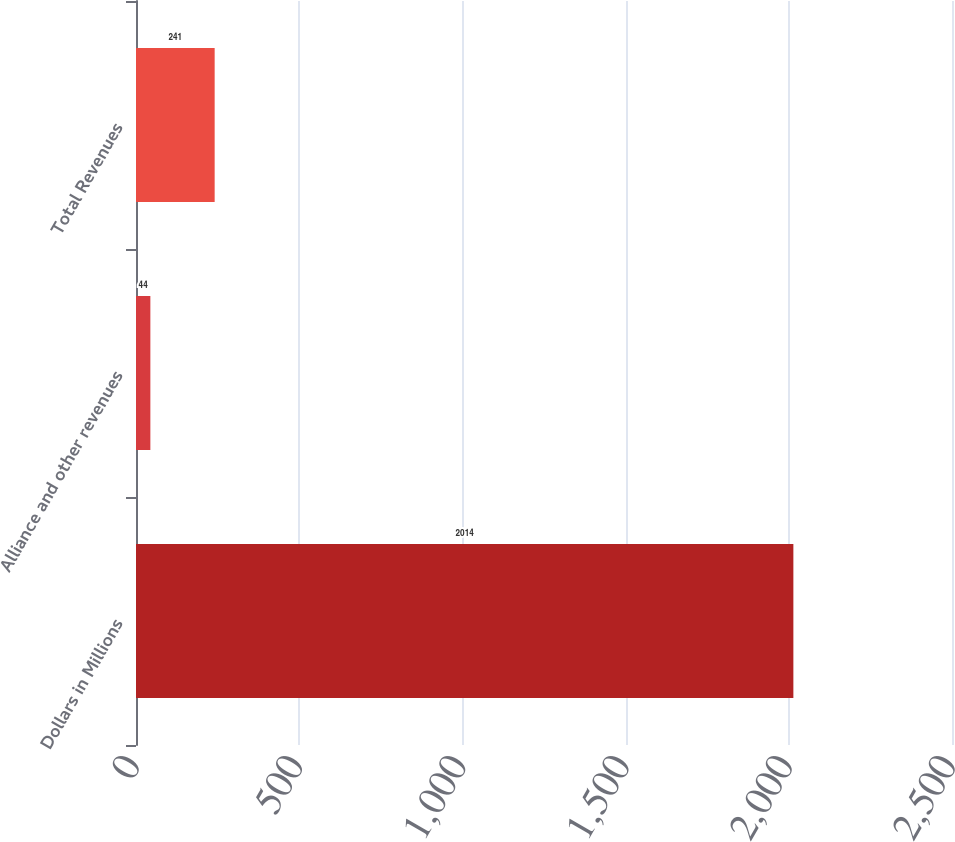<chart> <loc_0><loc_0><loc_500><loc_500><bar_chart><fcel>Dollars in Millions<fcel>Alliance and other revenues<fcel>Total Revenues<nl><fcel>2014<fcel>44<fcel>241<nl></chart> 